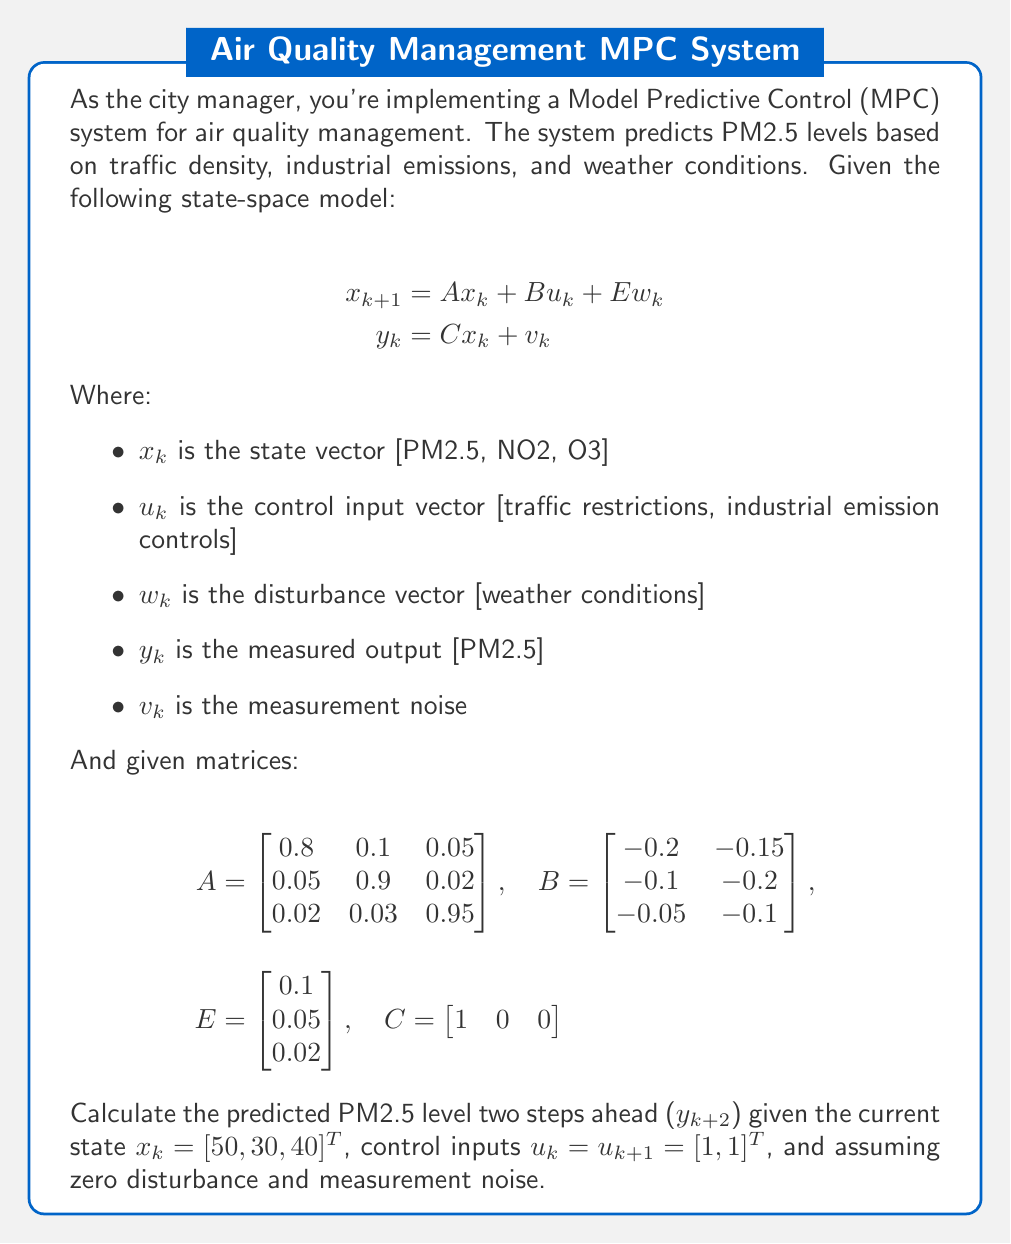Teach me how to tackle this problem. To solve this problem, we need to use the state-space model equations iteratively. Let's break it down step-by-step:

1. Calculate $x_{k+1}$:
   $$x_{k+1} = Ax_k + Bu_k + Ew_k$$
   
   Since we assume zero disturbance, $Ew_k = 0$. So:
   
   $$x_{k+1} = Ax_k + Bu_k$$

   $$x_{k+1} = \begin{bmatrix} 
   0.8 & 0.1 & 0.05 \\
   0.05 & 0.9 & 0.02 \\
   0.02 & 0.03 & 0.95
   \end{bmatrix} \begin{bmatrix} 50 \\ 30 \\ 40 \end{bmatrix} + 
   \begin{bmatrix}
   -0.2 & -0.15 \\
   -0.1 & -0.2 \\
   -0.05 & -0.1
   \end{bmatrix} \begin{bmatrix} 1 \\ 1 \end{bmatrix}$$

   $$x_{k+1} = \begin{bmatrix} 40 + 3 + 2 \\ 2.5 + 27 + 0.8 \\ 1 + 0.9 + 38 \end{bmatrix} + 
   \begin{bmatrix} -0.35 \\ -0.3 \\ -0.15 \end{bmatrix}$$

   $$x_{k+1} = \begin{bmatrix} 44.65 \\ 30 \\ 39.75 \end{bmatrix}$$

2. Calculate $x_{k+2}$:
   $$x_{k+2} = Ax_{k+1} + Bu_{k+1}$$

   $$x_{k+2} = \begin{bmatrix} 
   0.8 & 0.1 & 0.05 \\
   0.05 & 0.9 & 0.02 \\
   0.02 & 0.03 & 0.95
   \end{bmatrix} \begin{bmatrix} 44.65 \\ 30 \\ 39.75 \end{bmatrix} + 
   \begin{bmatrix}
   -0.2 & -0.15 \\
   -0.1 & -0.2 \\
   -0.05 & -0.1
   \end{bmatrix} \begin{bmatrix} 1 \\ 1 \end{bmatrix}$$

   $$x_{k+2} = \begin{bmatrix} 35.72 + 3 + 1.99 \\ 2.23 + 27 + 0.80 \\ 0.89 + 0.9 + 37.76 \end{bmatrix} + 
   \begin{bmatrix} -0.35 \\ -0.3 \\ -0.15 \end{bmatrix}$$

   $$x_{k+2} = \begin{bmatrix} 40.36 \\ 29.73 \\ 39.40 \end{bmatrix}$$

3. Calculate $y_{k+2}$:
   $$y_{k+2} = Cx_{k+2} + v_{k+2}$$
   
   Assuming zero measurement noise ($v_{k+2} = 0$):
   
   $$y_{k+2} = \begin{bmatrix} 1 & 0 & 0 \end{bmatrix} \begin{bmatrix} 40.36 \\ 29.73 \\ 39.40 \end{bmatrix}$$

   $$y_{k+2} = 40.36$$

Therefore, the predicted PM2.5 level two steps ahead is 40.36 μg/m³.
Answer: $y_{k+2} = 40.36$ μg/m³ 